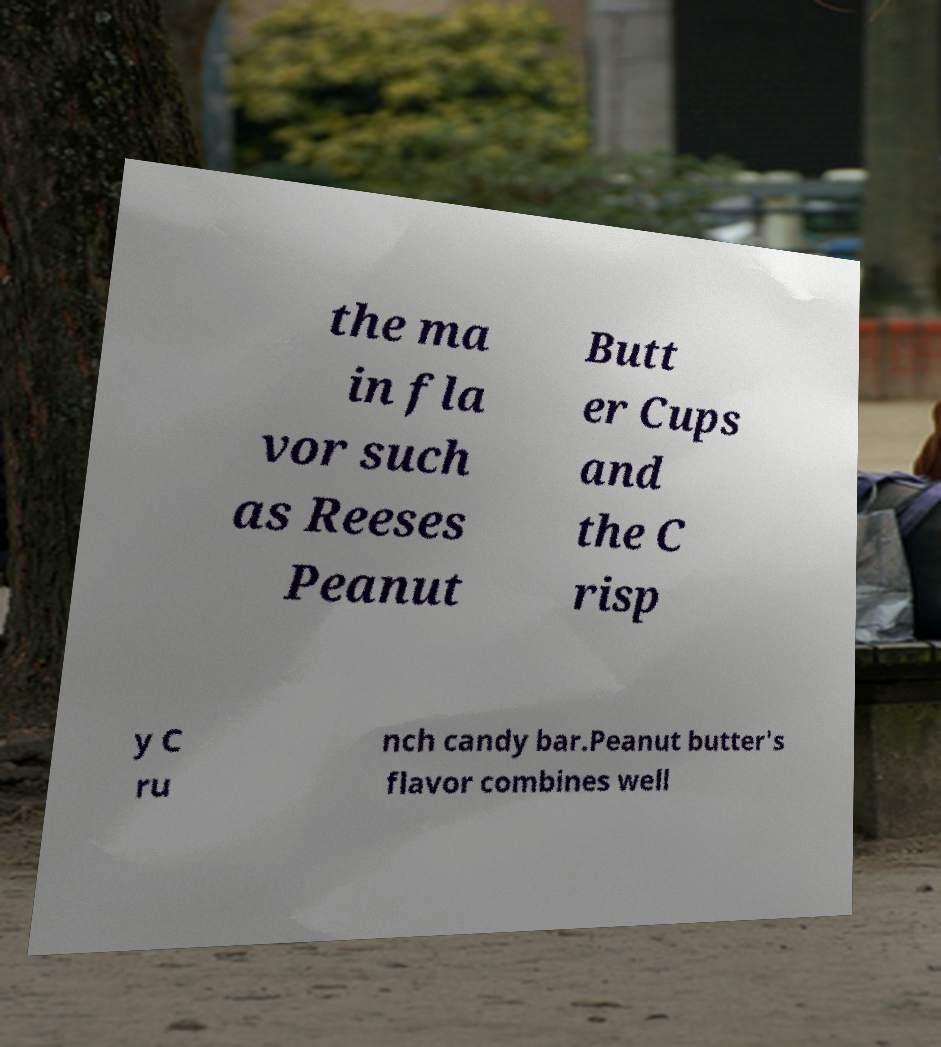Please identify and transcribe the text found in this image. the ma in fla vor such as Reeses Peanut Butt er Cups and the C risp y C ru nch candy bar.Peanut butter's flavor combines well 